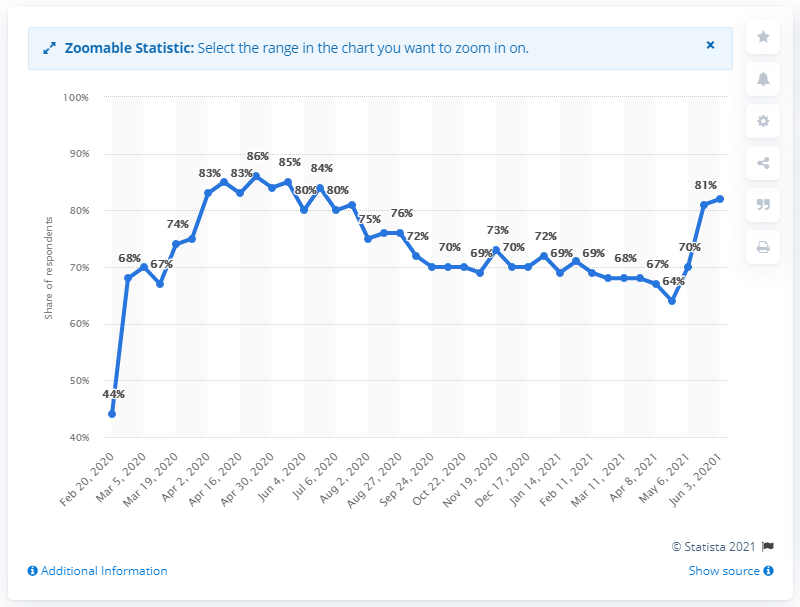Draw attention to some important aspects in this diagram. On February 21, 2020, a survey revealed that 44% of Singaporeans had been avoiding public places due to the COVID-19 outbreak. Of the Singaporeans surveyed, 82% reported avoiding public places during the COVID-19 outbreak as of June 3, 2021. 